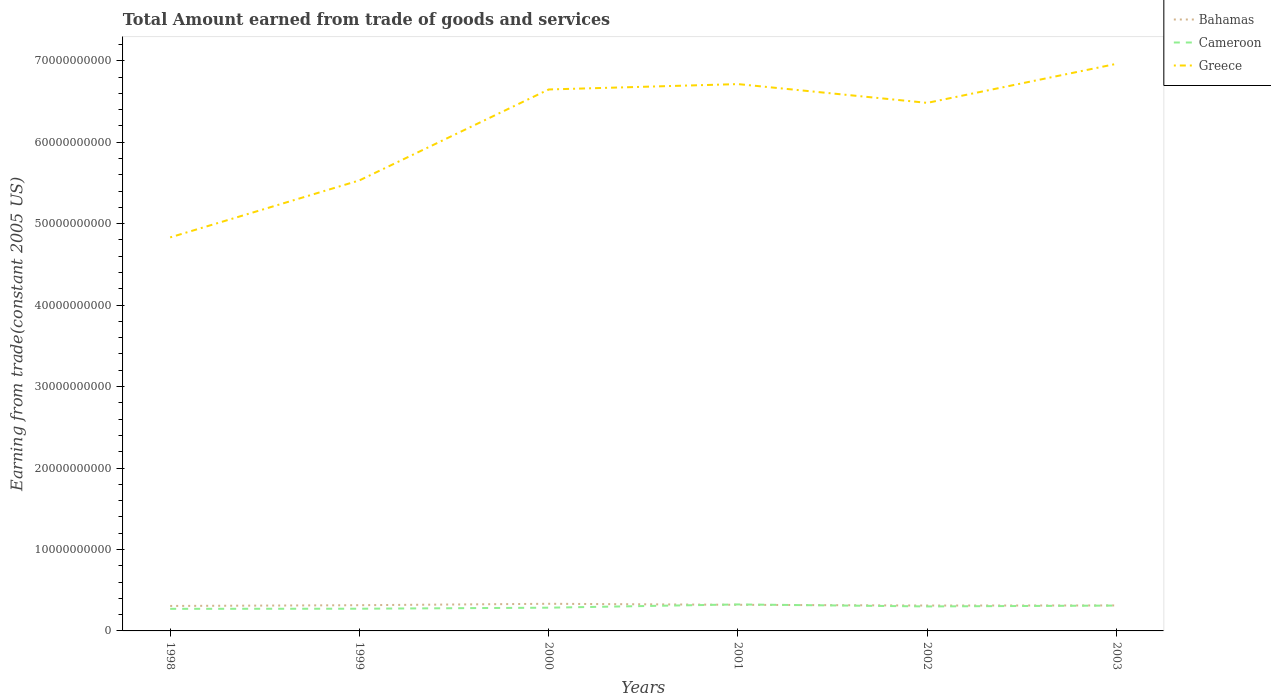How many different coloured lines are there?
Keep it short and to the point. 3. Does the line corresponding to Cameroon intersect with the line corresponding to Bahamas?
Your response must be concise. Yes. Is the number of lines equal to the number of legend labels?
Provide a succinct answer. Yes. Across all years, what is the maximum total amount earned by trading goods and services in Bahamas?
Ensure brevity in your answer.  3.07e+09. What is the total total amount earned by trading goods and services in Greece in the graph?
Your response must be concise. -2.13e+1. What is the difference between the highest and the second highest total amount earned by trading goods and services in Bahamas?
Give a very brief answer. 2.64e+08. What is the difference between the highest and the lowest total amount earned by trading goods and services in Greece?
Give a very brief answer. 4. Is the total amount earned by trading goods and services in Bahamas strictly greater than the total amount earned by trading goods and services in Cameroon over the years?
Make the answer very short. No. How many lines are there?
Give a very brief answer. 3. How many years are there in the graph?
Ensure brevity in your answer.  6. What is the difference between two consecutive major ticks on the Y-axis?
Your answer should be very brief. 1.00e+1. Are the values on the major ticks of Y-axis written in scientific E-notation?
Offer a very short reply. No. Does the graph contain any zero values?
Make the answer very short. No. Does the graph contain grids?
Ensure brevity in your answer.  No. What is the title of the graph?
Your response must be concise. Total Amount earned from trade of goods and services. Does "Micronesia" appear as one of the legend labels in the graph?
Provide a short and direct response. No. What is the label or title of the Y-axis?
Your answer should be very brief. Earning from trade(constant 2005 US). What is the Earning from trade(constant 2005 US) in Bahamas in 1998?
Provide a short and direct response. 3.07e+09. What is the Earning from trade(constant 2005 US) in Cameroon in 1998?
Provide a short and direct response. 2.71e+09. What is the Earning from trade(constant 2005 US) of Greece in 1998?
Your answer should be very brief. 4.83e+1. What is the Earning from trade(constant 2005 US) of Bahamas in 1999?
Offer a very short reply. 3.16e+09. What is the Earning from trade(constant 2005 US) in Cameroon in 1999?
Your answer should be very brief. 2.73e+09. What is the Earning from trade(constant 2005 US) in Greece in 1999?
Offer a terse response. 5.53e+1. What is the Earning from trade(constant 2005 US) of Bahamas in 2000?
Ensure brevity in your answer.  3.33e+09. What is the Earning from trade(constant 2005 US) in Cameroon in 2000?
Provide a succinct answer. 2.85e+09. What is the Earning from trade(constant 2005 US) in Greece in 2000?
Offer a very short reply. 6.65e+1. What is the Earning from trade(constant 2005 US) in Bahamas in 2001?
Provide a short and direct response. 3.21e+09. What is the Earning from trade(constant 2005 US) in Cameroon in 2001?
Offer a very short reply. 3.25e+09. What is the Earning from trade(constant 2005 US) of Greece in 2001?
Keep it short and to the point. 6.71e+1. What is the Earning from trade(constant 2005 US) of Bahamas in 2002?
Give a very brief answer. 3.12e+09. What is the Earning from trade(constant 2005 US) of Cameroon in 2002?
Your response must be concise. 3.01e+09. What is the Earning from trade(constant 2005 US) in Greece in 2002?
Provide a succinct answer. 6.48e+1. What is the Earning from trade(constant 2005 US) of Bahamas in 2003?
Offer a terse response. 3.13e+09. What is the Earning from trade(constant 2005 US) in Cameroon in 2003?
Provide a succinct answer. 3.11e+09. What is the Earning from trade(constant 2005 US) of Greece in 2003?
Your answer should be very brief. 6.96e+1. Across all years, what is the maximum Earning from trade(constant 2005 US) of Bahamas?
Provide a short and direct response. 3.33e+09. Across all years, what is the maximum Earning from trade(constant 2005 US) in Cameroon?
Give a very brief answer. 3.25e+09. Across all years, what is the maximum Earning from trade(constant 2005 US) in Greece?
Your answer should be compact. 6.96e+1. Across all years, what is the minimum Earning from trade(constant 2005 US) of Bahamas?
Your response must be concise. 3.07e+09. Across all years, what is the minimum Earning from trade(constant 2005 US) of Cameroon?
Your answer should be compact. 2.71e+09. Across all years, what is the minimum Earning from trade(constant 2005 US) in Greece?
Offer a very short reply. 4.83e+1. What is the total Earning from trade(constant 2005 US) of Bahamas in the graph?
Make the answer very short. 1.90e+1. What is the total Earning from trade(constant 2005 US) of Cameroon in the graph?
Keep it short and to the point. 1.77e+1. What is the total Earning from trade(constant 2005 US) in Greece in the graph?
Your answer should be very brief. 3.72e+11. What is the difference between the Earning from trade(constant 2005 US) of Bahamas in 1998 and that in 1999?
Provide a short and direct response. -9.12e+07. What is the difference between the Earning from trade(constant 2005 US) in Cameroon in 1998 and that in 1999?
Give a very brief answer. -1.45e+07. What is the difference between the Earning from trade(constant 2005 US) in Greece in 1998 and that in 1999?
Your response must be concise. -7.00e+09. What is the difference between the Earning from trade(constant 2005 US) of Bahamas in 1998 and that in 2000?
Keep it short and to the point. -2.64e+08. What is the difference between the Earning from trade(constant 2005 US) of Cameroon in 1998 and that in 2000?
Keep it short and to the point. -1.41e+08. What is the difference between the Earning from trade(constant 2005 US) of Greece in 1998 and that in 2000?
Your response must be concise. -1.82e+1. What is the difference between the Earning from trade(constant 2005 US) in Bahamas in 1998 and that in 2001?
Make the answer very short. -1.39e+08. What is the difference between the Earning from trade(constant 2005 US) in Cameroon in 1998 and that in 2001?
Give a very brief answer. -5.41e+08. What is the difference between the Earning from trade(constant 2005 US) of Greece in 1998 and that in 2001?
Your answer should be compact. -1.88e+1. What is the difference between the Earning from trade(constant 2005 US) in Bahamas in 1998 and that in 2002?
Your answer should be very brief. -4.97e+07. What is the difference between the Earning from trade(constant 2005 US) of Cameroon in 1998 and that in 2002?
Your response must be concise. -2.94e+08. What is the difference between the Earning from trade(constant 2005 US) of Greece in 1998 and that in 2002?
Offer a very short reply. -1.65e+1. What is the difference between the Earning from trade(constant 2005 US) in Bahamas in 1998 and that in 2003?
Your answer should be compact. -6.03e+07. What is the difference between the Earning from trade(constant 2005 US) of Cameroon in 1998 and that in 2003?
Keep it short and to the point. -4.02e+08. What is the difference between the Earning from trade(constant 2005 US) in Greece in 1998 and that in 2003?
Give a very brief answer. -2.13e+1. What is the difference between the Earning from trade(constant 2005 US) in Bahamas in 1999 and that in 2000?
Keep it short and to the point. -1.73e+08. What is the difference between the Earning from trade(constant 2005 US) in Cameroon in 1999 and that in 2000?
Make the answer very short. -1.26e+08. What is the difference between the Earning from trade(constant 2005 US) in Greece in 1999 and that in 2000?
Make the answer very short. -1.12e+1. What is the difference between the Earning from trade(constant 2005 US) of Bahamas in 1999 and that in 2001?
Keep it short and to the point. -4.74e+07. What is the difference between the Earning from trade(constant 2005 US) of Cameroon in 1999 and that in 2001?
Give a very brief answer. -5.27e+08. What is the difference between the Earning from trade(constant 2005 US) of Greece in 1999 and that in 2001?
Provide a succinct answer. -1.18e+1. What is the difference between the Earning from trade(constant 2005 US) in Bahamas in 1999 and that in 2002?
Provide a short and direct response. 4.15e+07. What is the difference between the Earning from trade(constant 2005 US) of Cameroon in 1999 and that in 2002?
Your response must be concise. -2.79e+08. What is the difference between the Earning from trade(constant 2005 US) of Greece in 1999 and that in 2002?
Give a very brief answer. -9.52e+09. What is the difference between the Earning from trade(constant 2005 US) of Bahamas in 1999 and that in 2003?
Offer a very short reply. 3.08e+07. What is the difference between the Earning from trade(constant 2005 US) of Cameroon in 1999 and that in 2003?
Keep it short and to the point. -3.87e+08. What is the difference between the Earning from trade(constant 2005 US) in Greece in 1999 and that in 2003?
Your answer should be very brief. -1.43e+1. What is the difference between the Earning from trade(constant 2005 US) in Bahamas in 2000 and that in 2001?
Offer a very short reply. 1.26e+08. What is the difference between the Earning from trade(constant 2005 US) in Cameroon in 2000 and that in 2001?
Offer a very short reply. -4.00e+08. What is the difference between the Earning from trade(constant 2005 US) of Greece in 2000 and that in 2001?
Keep it short and to the point. -6.59e+08. What is the difference between the Earning from trade(constant 2005 US) in Bahamas in 2000 and that in 2002?
Make the answer very short. 2.15e+08. What is the difference between the Earning from trade(constant 2005 US) of Cameroon in 2000 and that in 2002?
Make the answer very short. -1.53e+08. What is the difference between the Earning from trade(constant 2005 US) in Greece in 2000 and that in 2002?
Provide a succinct answer. 1.65e+09. What is the difference between the Earning from trade(constant 2005 US) of Bahamas in 2000 and that in 2003?
Keep it short and to the point. 2.04e+08. What is the difference between the Earning from trade(constant 2005 US) in Cameroon in 2000 and that in 2003?
Offer a very short reply. -2.61e+08. What is the difference between the Earning from trade(constant 2005 US) in Greece in 2000 and that in 2003?
Offer a terse response. -3.15e+09. What is the difference between the Earning from trade(constant 2005 US) of Bahamas in 2001 and that in 2002?
Your response must be concise. 8.88e+07. What is the difference between the Earning from trade(constant 2005 US) in Cameroon in 2001 and that in 2002?
Your response must be concise. 2.47e+08. What is the difference between the Earning from trade(constant 2005 US) of Greece in 2001 and that in 2002?
Your response must be concise. 2.30e+09. What is the difference between the Earning from trade(constant 2005 US) of Bahamas in 2001 and that in 2003?
Your response must be concise. 7.82e+07. What is the difference between the Earning from trade(constant 2005 US) in Cameroon in 2001 and that in 2003?
Keep it short and to the point. 1.39e+08. What is the difference between the Earning from trade(constant 2005 US) of Greece in 2001 and that in 2003?
Give a very brief answer. -2.49e+09. What is the difference between the Earning from trade(constant 2005 US) of Bahamas in 2002 and that in 2003?
Your response must be concise. -1.06e+07. What is the difference between the Earning from trade(constant 2005 US) in Cameroon in 2002 and that in 2003?
Make the answer very short. -1.08e+08. What is the difference between the Earning from trade(constant 2005 US) of Greece in 2002 and that in 2003?
Your response must be concise. -4.79e+09. What is the difference between the Earning from trade(constant 2005 US) in Bahamas in 1998 and the Earning from trade(constant 2005 US) in Cameroon in 1999?
Provide a succinct answer. 3.41e+08. What is the difference between the Earning from trade(constant 2005 US) in Bahamas in 1998 and the Earning from trade(constant 2005 US) in Greece in 1999?
Provide a succinct answer. -5.22e+1. What is the difference between the Earning from trade(constant 2005 US) of Cameroon in 1998 and the Earning from trade(constant 2005 US) of Greece in 1999?
Make the answer very short. -5.26e+1. What is the difference between the Earning from trade(constant 2005 US) in Bahamas in 1998 and the Earning from trade(constant 2005 US) in Cameroon in 2000?
Make the answer very short. 2.14e+08. What is the difference between the Earning from trade(constant 2005 US) of Bahamas in 1998 and the Earning from trade(constant 2005 US) of Greece in 2000?
Your response must be concise. -6.34e+1. What is the difference between the Earning from trade(constant 2005 US) of Cameroon in 1998 and the Earning from trade(constant 2005 US) of Greece in 2000?
Provide a succinct answer. -6.38e+1. What is the difference between the Earning from trade(constant 2005 US) in Bahamas in 1998 and the Earning from trade(constant 2005 US) in Cameroon in 2001?
Keep it short and to the point. -1.86e+08. What is the difference between the Earning from trade(constant 2005 US) of Bahamas in 1998 and the Earning from trade(constant 2005 US) of Greece in 2001?
Your answer should be very brief. -6.41e+1. What is the difference between the Earning from trade(constant 2005 US) of Cameroon in 1998 and the Earning from trade(constant 2005 US) of Greece in 2001?
Offer a very short reply. -6.44e+1. What is the difference between the Earning from trade(constant 2005 US) of Bahamas in 1998 and the Earning from trade(constant 2005 US) of Cameroon in 2002?
Offer a terse response. 6.16e+07. What is the difference between the Earning from trade(constant 2005 US) of Bahamas in 1998 and the Earning from trade(constant 2005 US) of Greece in 2002?
Ensure brevity in your answer.  -6.18e+1. What is the difference between the Earning from trade(constant 2005 US) of Cameroon in 1998 and the Earning from trade(constant 2005 US) of Greece in 2002?
Provide a short and direct response. -6.21e+1. What is the difference between the Earning from trade(constant 2005 US) in Bahamas in 1998 and the Earning from trade(constant 2005 US) in Cameroon in 2003?
Ensure brevity in your answer.  -4.66e+07. What is the difference between the Earning from trade(constant 2005 US) in Bahamas in 1998 and the Earning from trade(constant 2005 US) in Greece in 2003?
Ensure brevity in your answer.  -6.66e+1. What is the difference between the Earning from trade(constant 2005 US) in Cameroon in 1998 and the Earning from trade(constant 2005 US) in Greece in 2003?
Your response must be concise. -6.69e+1. What is the difference between the Earning from trade(constant 2005 US) of Bahamas in 1999 and the Earning from trade(constant 2005 US) of Cameroon in 2000?
Ensure brevity in your answer.  3.06e+08. What is the difference between the Earning from trade(constant 2005 US) in Bahamas in 1999 and the Earning from trade(constant 2005 US) in Greece in 2000?
Make the answer very short. -6.33e+1. What is the difference between the Earning from trade(constant 2005 US) in Cameroon in 1999 and the Earning from trade(constant 2005 US) in Greece in 2000?
Your response must be concise. -6.37e+1. What is the difference between the Earning from trade(constant 2005 US) of Bahamas in 1999 and the Earning from trade(constant 2005 US) of Cameroon in 2001?
Offer a terse response. -9.47e+07. What is the difference between the Earning from trade(constant 2005 US) of Bahamas in 1999 and the Earning from trade(constant 2005 US) of Greece in 2001?
Ensure brevity in your answer.  -6.40e+1. What is the difference between the Earning from trade(constant 2005 US) in Cameroon in 1999 and the Earning from trade(constant 2005 US) in Greece in 2001?
Your answer should be compact. -6.44e+1. What is the difference between the Earning from trade(constant 2005 US) in Bahamas in 1999 and the Earning from trade(constant 2005 US) in Cameroon in 2002?
Give a very brief answer. 1.53e+08. What is the difference between the Earning from trade(constant 2005 US) in Bahamas in 1999 and the Earning from trade(constant 2005 US) in Greece in 2002?
Make the answer very short. -6.17e+1. What is the difference between the Earning from trade(constant 2005 US) of Cameroon in 1999 and the Earning from trade(constant 2005 US) of Greece in 2002?
Offer a very short reply. -6.21e+1. What is the difference between the Earning from trade(constant 2005 US) of Bahamas in 1999 and the Earning from trade(constant 2005 US) of Cameroon in 2003?
Offer a very short reply. 4.46e+07. What is the difference between the Earning from trade(constant 2005 US) of Bahamas in 1999 and the Earning from trade(constant 2005 US) of Greece in 2003?
Your answer should be very brief. -6.65e+1. What is the difference between the Earning from trade(constant 2005 US) of Cameroon in 1999 and the Earning from trade(constant 2005 US) of Greece in 2003?
Keep it short and to the point. -6.69e+1. What is the difference between the Earning from trade(constant 2005 US) in Bahamas in 2000 and the Earning from trade(constant 2005 US) in Cameroon in 2001?
Offer a terse response. 7.85e+07. What is the difference between the Earning from trade(constant 2005 US) in Bahamas in 2000 and the Earning from trade(constant 2005 US) in Greece in 2001?
Provide a succinct answer. -6.38e+1. What is the difference between the Earning from trade(constant 2005 US) in Cameroon in 2000 and the Earning from trade(constant 2005 US) in Greece in 2001?
Ensure brevity in your answer.  -6.43e+1. What is the difference between the Earning from trade(constant 2005 US) of Bahamas in 2000 and the Earning from trade(constant 2005 US) of Cameroon in 2002?
Keep it short and to the point. 3.26e+08. What is the difference between the Earning from trade(constant 2005 US) in Bahamas in 2000 and the Earning from trade(constant 2005 US) in Greece in 2002?
Your answer should be very brief. -6.15e+1. What is the difference between the Earning from trade(constant 2005 US) of Cameroon in 2000 and the Earning from trade(constant 2005 US) of Greece in 2002?
Your answer should be compact. -6.20e+1. What is the difference between the Earning from trade(constant 2005 US) in Bahamas in 2000 and the Earning from trade(constant 2005 US) in Cameroon in 2003?
Provide a succinct answer. 2.18e+08. What is the difference between the Earning from trade(constant 2005 US) in Bahamas in 2000 and the Earning from trade(constant 2005 US) in Greece in 2003?
Make the answer very short. -6.63e+1. What is the difference between the Earning from trade(constant 2005 US) in Cameroon in 2000 and the Earning from trade(constant 2005 US) in Greece in 2003?
Keep it short and to the point. -6.68e+1. What is the difference between the Earning from trade(constant 2005 US) of Bahamas in 2001 and the Earning from trade(constant 2005 US) of Cameroon in 2002?
Ensure brevity in your answer.  2.00e+08. What is the difference between the Earning from trade(constant 2005 US) in Bahamas in 2001 and the Earning from trade(constant 2005 US) in Greece in 2002?
Ensure brevity in your answer.  -6.16e+1. What is the difference between the Earning from trade(constant 2005 US) of Cameroon in 2001 and the Earning from trade(constant 2005 US) of Greece in 2002?
Keep it short and to the point. -6.16e+1. What is the difference between the Earning from trade(constant 2005 US) in Bahamas in 2001 and the Earning from trade(constant 2005 US) in Cameroon in 2003?
Ensure brevity in your answer.  9.19e+07. What is the difference between the Earning from trade(constant 2005 US) of Bahamas in 2001 and the Earning from trade(constant 2005 US) of Greece in 2003?
Offer a very short reply. -6.64e+1. What is the difference between the Earning from trade(constant 2005 US) of Cameroon in 2001 and the Earning from trade(constant 2005 US) of Greece in 2003?
Give a very brief answer. -6.64e+1. What is the difference between the Earning from trade(constant 2005 US) of Bahamas in 2002 and the Earning from trade(constant 2005 US) of Cameroon in 2003?
Provide a succinct answer. 3.10e+06. What is the difference between the Earning from trade(constant 2005 US) of Bahamas in 2002 and the Earning from trade(constant 2005 US) of Greece in 2003?
Provide a succinct answer. -6.65e+1. What is the difference between the Earning from trade(constant 2005 US) in Cameroon in 2002 and the Earning from trade(constant 2005 US) in Greece in 2003?
Make the answer very short. -6.66e+1. What is the average Earning from trade(constant 2005 US) in Bahamas per year?
Your response must be concise. 3.17e+09. What is the average Earning from trade(constant 2005 US) in Cameroon per year?
Give a very brief answer. 2.94e+09. What is the average Earning from trade(constant 2005 US) of Greece per year?
Your response must be concise. 6.19e+1. In the year 1998, what is the difference between the Earning from trade(constant 2005 US) in Bahamas and Earning from trade(constant 2005 US) in Cameroon?
Your answer should be very brief. 3.55e+08. In the year 1998, what is the difference between the Earning from trade(constant 2005 US) of Bahamas and Earning from trade(constant 2005 US) of Greece?
Ensure brevity in your answer.  -4.52e+1. In the year 1998, what is the difference between the Earning from trade(constant 2005 US) of Cameroon and Earning from trade(constant 2005 US) of Greece?
Provide a succinct answer. -4.56e+1. In the year 1999, what is the difference between the Earning from trade(constant 2005 US) in Bahamas and Earning from trade(constant 2005 US) in Cameroon?
Offer a very short reply. 4.32e+08. In the year 1999, what is the difference between the Earning from trade(constant 2005 US) of Bahamas and Earning from trade(constant 2005 US) of Greece?
Offer a very short reply. -5.22e+1. In the year 1999, what is the difference between the Earning from trade(constant 2005 US) in Cameroon and Earning from trade(constant 2005 US) in Greece?
Offer a very short reply. -5.26e+1. In the year 2000, what is the difference between the Earning from trade(constant 2005 US) in Bahamas and Earning from trade(constant 2005 US) in Cameroon?
Ensure brevity in your answer.  4.79e+08. In the year 2000, what is the difference between the Earning from trade(constant 2005 US) of Bahamas and Earning from trade(constant 2005 US) of Greece?
Keep it short and to the point. -6.31e+1. In the year 2000, what is the difference between the Earning from trade(constant 2005 US) of Cameroon and Earning from trade(constant 2005 US) of Greece?
Offer a very short reply. -6.36e+1. In the year 2001, what is the difference between the Earning from trade(constant 2005 US) of Bahamas and Earning from trade(constant 2005 US) of Cameroon?
Provide a short and direct response. -4.73e+07. In the year 2001, what is the difference between the Earning from trade(constant 2005 US) of Bahamas and Earning from trade(constant 2005 US) of Greece?
Keep it short and to the point. -6.39e+1. In the year 2001, what is the difference between the Earning from trade(constant 2005 US) of Cameroon and Earning from trade(constant 2005 US) of Greece?
Make the answer very short. -6.39e+1. In the year 2002, what is the difference between the Earning from trade(constant 2005 US) in Bahamas and Earning from trade(constant 2005 US) in Cameroon?
Your answer should be very brief. 1.11e+08. In the year 2002, what is the difference between the Earning from trade(constant 2005 US) of Bahamas and Earning from trade(constant 2005 US) of Greece?
Keep it short and to the point. -6.17e+1. In the year 2002, what is the difference between the Earning from trade(constant 2005 US) in Cameroon and Earning from trade(constant 2005 US) in Greece?
Ensure brevity in your answer.  -6.18e+1. In the year 2003, what is the difference between the Earning from trade(constant 2005 US) of Bahamas and Earning from trade(constant 2005 US) of Cameroon?
Provide a short and direct response. 1.37e+07. In the year 2003, what is the difference between the Earning from trade(constant 2005 US) of Bahamas and Earning from trade(constant 2005 US) of Greece?
Your response must be concise. -6.65e+1. In the year 2003, what is the difference between the Earning from trade(constant 2005 US) of Cameroon and Earning from trade(constant 2005 US) of Greece?
Keep it short and to the point. -6.65e+1. What is the ratio of the Earning from trade(constant 2005 US) of Bahamas in 1998 to that in 1999?
Provide a succinct answer. 0.97. What is the ratio of the Earning from trade(constant 2005 US) in Greece in 1998 to that in 1999?
Your response must be concise. 0.87. What is the ratio of the Earning from trade(constant 2005 US) of Bahamas in 1998 to that in 2000?
Your answer should be compact. 0.92. What is the ratio of the Earning from trade(constant 2005 US) in Cameroon in 1998 to that in 2000?
Provide a short and direct response. 0.95. What is the ratio of the Earning from trade(constant 2005 US) in Greece in 1998 to that in 2000?
Give a very brief answer. 0.73. What is the ratio of the Earning from trade(constant 2005 US) in Bahamas in 1998 to that in 2001?
Give a very brief answer. 0.96. What is the ratio of the Earning from trade(constant 2005 US) of Cameroon in 1998 to that in 2001?
Your answer should be compact. 0.83. What is the ratio of the Earning from trade(constant 2005 US) in Greece in 1998 to that in 2001?
Provide a short and direct response. 0.72. What is the ratio of the Earning from trade(constant 2005 US) of Bahamas in 1998 to that in 2002?
Make the answer very short. 0.98. What is the ratio of the Earning from trade(constant 2005 US) in Cameroon in 1998 to that in 2002?
Ensure brevity in your answer.  0.9. What is the ratio of the Earning from trade(constant 2005 US) of Greece in 1998 to that in 2002?
Provide a succinct answer. 0.75. What is the ratio of the Earning from trade(constant 2005 US) in Bahamas in 1998 to that in 2003?
Keep it short and to the point. 0.98. What is the ratio of the Earning from trade(constant 2005 US) of Cameroon in 1998 to that in 2003?
Provide a succinct answer. 0.87. What is the ratio of the Earning from trade(constant 2005 US) in Greece in 1998 to that in 2003?
Your response must be concise. 0.69. What is the ratio of the Earning from trade(constant 2005 US) of Bahamas in 1999 to that in 2000?
Provide a short and direct response. 0.95. What is the ratio of the Earning from trade(constant 2005 US) of Cameroon in 1999 to that in 2000?
Keep it short and to the point. 0.96. What is the ratio of the Earning from trade(constant 2005 US) in Greece in 1999 to that in 2000?
Make the answer very short. 0.83. What is the ratio of the Earning from trade(constant 2005 US) in Bahamas in 1999 to that in 2001?
Provide a short and direct response. 0.99. What is the ratio of the Earning from trade(constant 2005 US) of Cameroon in 1999 to that in 2001?
Your answer should be compact. 0.84. What is the ratio of the Earning from trade(constant 2005 US) of Greece in 1999 to that in 2001?
Ensure brevity in your answer.  0.82. What is the ratio of the Earning from trade(constant 2005 US) in Bahamas in 1999 to that in 2002?
Provide a short and direct response. 1.01. What is the ratio of the Earning from trade(constant 2005 US) of Cameroon in 1999 to that in 2002?
Keep it short and to the point. 0.91. What is the ratio of the Earning from trade(constant 2005 US) in Greece in 1999 to that in 2002?
Offer a terse response. 0.85. What is the ratio of the Earning from trade(constant 2005 US) of Bahamas in 1999 to that in 2003?
Ensure brevity in your answer.  1.01. What is the ratio of the Earning from trade(constant 2005 US) of Cameroon in 1999 to that in 2003?
Offer a terse response. 0.88. What is the ratio of the Earning from trade(constant 2005 US) in Greece in 1999 to that in 2003?
Ensure brevity in your answer.  0.79. What is the ratio of the Earning from trade(constant 2005 US) of Bahamas in 2000 to that in 2001?
Give a very brief answer. 1.04. What is the ratio of the Earning from trade(constant 2005 US) in Cameroon in 2000 to that in 2001?
Keep it short and to the point. 0.88. What is the ratio of the Earning from trade(constant 2005 US) in Greece in 2000 to that in 2001?
Your answer should be very brief. 0.99. What is the ratio of the Earning from trade(constant 2005 US) of Bahamas in 2000 to that in 2002?
Provide a short and direct response. 1.07. What is the ratio of the Earning from trade(constant 2005 US) of Cameroon in 2000 to that in 2002?
Your answer should be very brief. 0.95. What is the ratio of the Earning from trade(constant 2005 US) in Greece in 2000 to that in 2002?
Make the answer very short. 1.03. What is the ratio of the Earning from trade(constant 2005 US) of Bahamas in 2000 to that in 2003?
Provide a short and direct response. 1.07. What is the ratio of the Earning from trade(constant 2005 US) in Cameroon in 2000 to that in 2003?
Give a very brief answer. 0.92. What is the ratio of the Earning from trade(constant 2005 US) of Greece in 2000 to that in 2003?
Ensure brevity in your answer.  0.95. What is the ratio of the Earning from trade(constant 2005 US) of Bahamas in 2001 to that in 2002?
Your answer should be compact. 1.03. What is the ratio of the Earning from trade(constant 2005 US) in Cameroon in 2001 to that in 2002?
Offer a very short reply. 1.08. What is the ratio of the Earning from trade(constant 2005 US) of Greece in 2001 to that in 2002?
Provide a succinct answer. 1.04. What is the ratio of the Earning from trade(constant 2005 US) in Bahamas in 2001 to that in 2003?
Give a very brief answer. 1.02. What is the ratio of the Earning from trade(constant 2005 US) in Cameroon in 2001 to that in 2003?
Your answer should be very brief. 1.04. What is the ratio of the Earning from trade(constant 2005 US) of Greece in 2001 to that in 2003?
Keep it short and to the point. 0.96. What is the ratio of the Earning from trade(constant 2005 US) in Bahamas in 2002 to that in 2003?
Make the answer very short. 1. What is the ratio of the Earning from trade(constant 2005 US) in Cameroon in 2002 to that in 2003?
Your answer should be compact. 0.97. What is the ratio of the Earning from trade(constant 2005 US) in Greece in 2002 to that in 2003?
Ensure brevity in your answer.  0.93. What is the difference between the highest and the second highest Earning from trade(constant 2005 US) of Bahamas?
Make the answer very short. 1.26e+08. What is the difference between the highest and the second highest Earning from trade(constant 2005 US) of Cameroon?
Offer a terse response. 1.39e+08. What is the difference between the highest and the second highest Earning from trade(constant 2005 US) of Greece?
Offer a terse response. 2.49e+09. What is the difference between the highest and the lowest Earning from trade(constant 2005 US) of Bahamas?
Your response must be concise. 2.64e+08. What is the difference between the highest and the lowest Earning from trade(constant 2005 US) of Cameroon?
Your response must be concise. 5.41e+08. What is the difference between the highest and the lowest Earning from trade(constant 2005 US) in Greece?
Ensure brevity in your answer.  2.13e+1. 